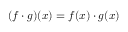<formula> <loc_0><loc_0><loc_500><loc_500>( f \cdot g ) ( x ) = f ( x ) \cdot g ( x )</formula> 